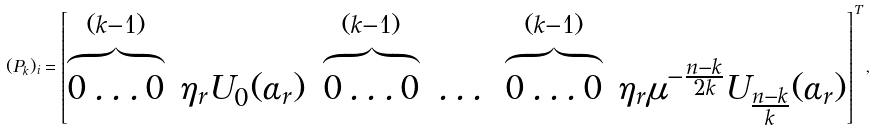Convert formula to latex. <formula><loc_0><loc_0><loc_500><loc_500>( P _ { k } ) _ { i } = \begin{bmatrix} \overbrace { 0 \dots 0 } ^ { ( k - 1 ) } & \eta _ { r } U _ { 0 } ( \alpha _ { r } ) & \overbrace { 0 \dots 0 } ^ { ( k - 1 ) } & \dots & \overbrace { 0 \dots 0 } ^ { ( k - 1 ) } & \eta _ { r } \mu ^ { - \frac { n - k } { 2 k } } U _ { \frac { n - k } { k } } ( \alpha _ { r } ) \end{bmatrix} ^ { T } ,</formula> 